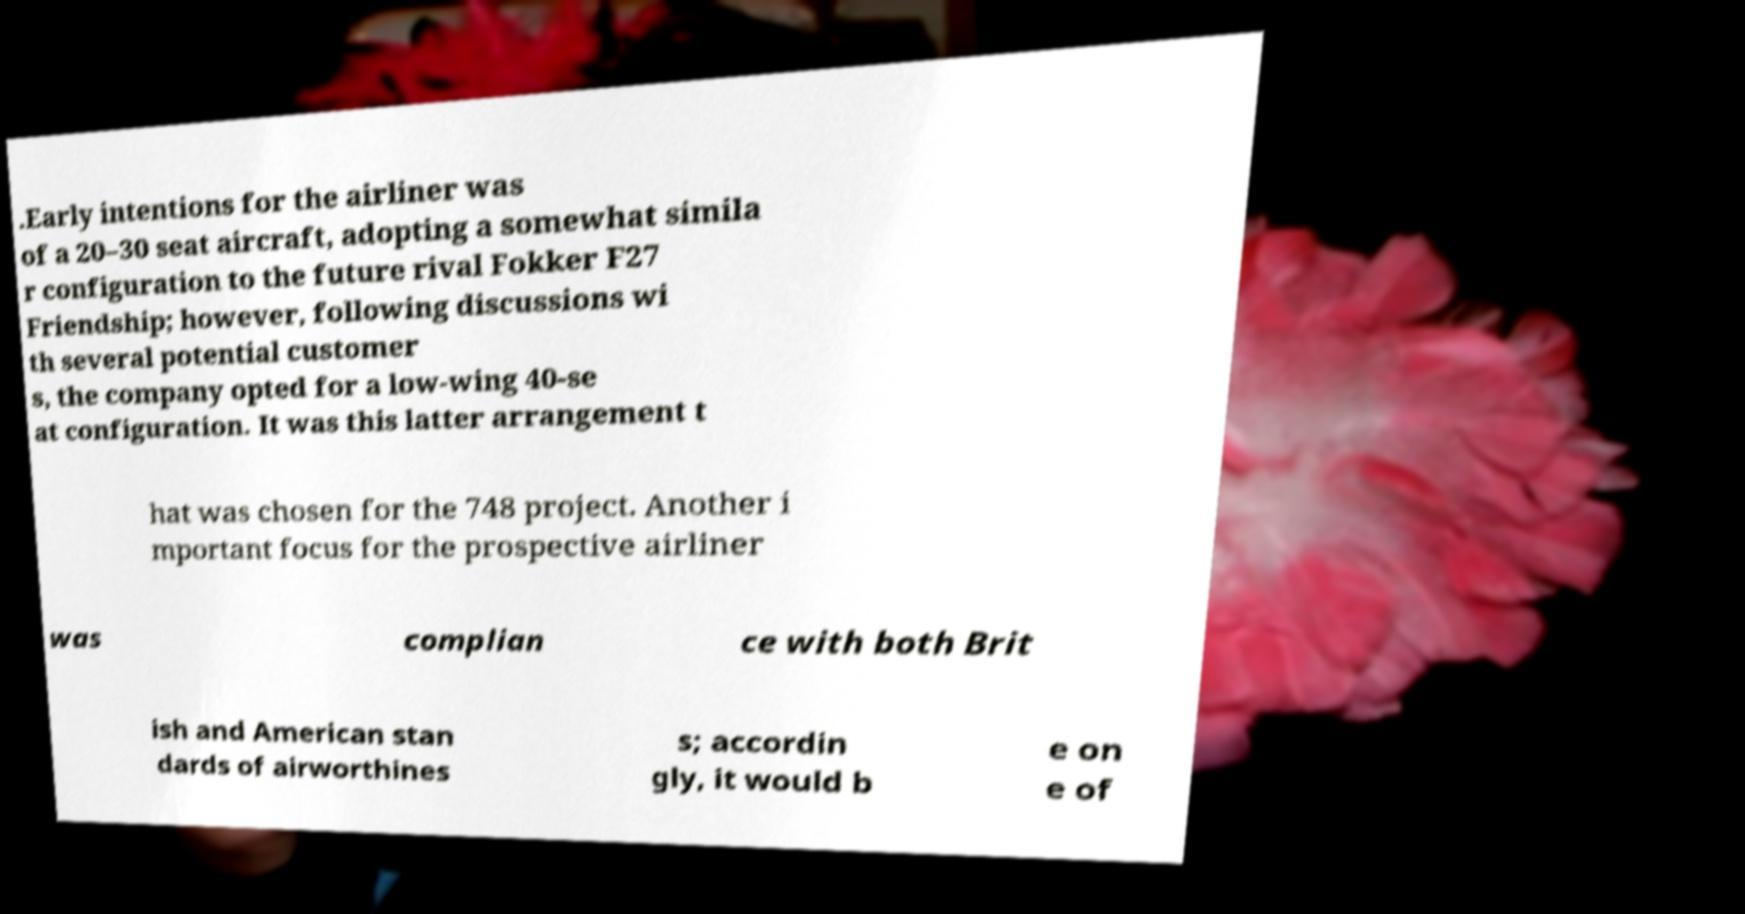For documentation purposes, I need the text within this image transcribed. Could you provide that? .Early intentions for the airliner was of a 20–30 seat aircraft, adopting a somewhat simila r configuration to the future rival Fokker F27 Friendship; however, following discussions wi th several potential customer s, the company opted for a low-wing 40-se at configuration. It was this latter arrangement t hat was chosen for the 748 project. Another i mportant focus for the prospective airliner was complian ce with both Brit ish and American stan dards of airworthines s; accordin gly, it would b e on e of 